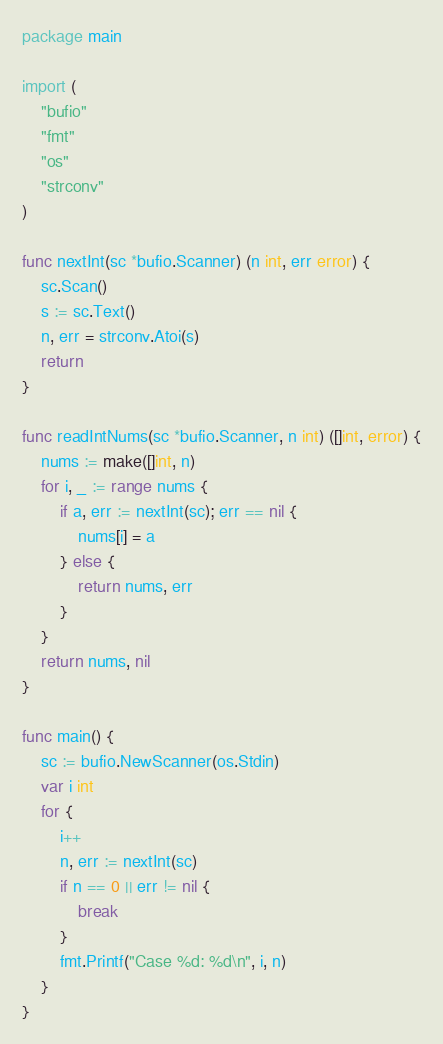Convert code to text. <code><loc_0><loc_0><loc_500><loc_500><_Go_>package main

import (
	"bufio"
	"fmt"
	"os"
	"strconv"
)

func nextInt(sc *bufio.Scanner) (n int, err error) {
	sc.Scan()
	s := sc.Text()
	n, err = strconv.Atoi(s)
	return
}

func readIntNums(sc *bufio.Scanner, n int) ([]int, error) {
	nums := make([]int, n)
	for i, _ := range nums {
		if a, err := nextInt(sc); err == nil {
			nums[i] = a
		} else {
			return nums, err
		}
	}
	return nums, nil
}

func main() {
	sc := bufio.NewScanner(os.Stdin)
	var i int
	for {
		i++
		n, err := nextInt(sc)
		if n == 0 || err != nil {
			break
		}
		fmt.Printf("Case %d: %d\n", i, n)
	}
}

</code> 